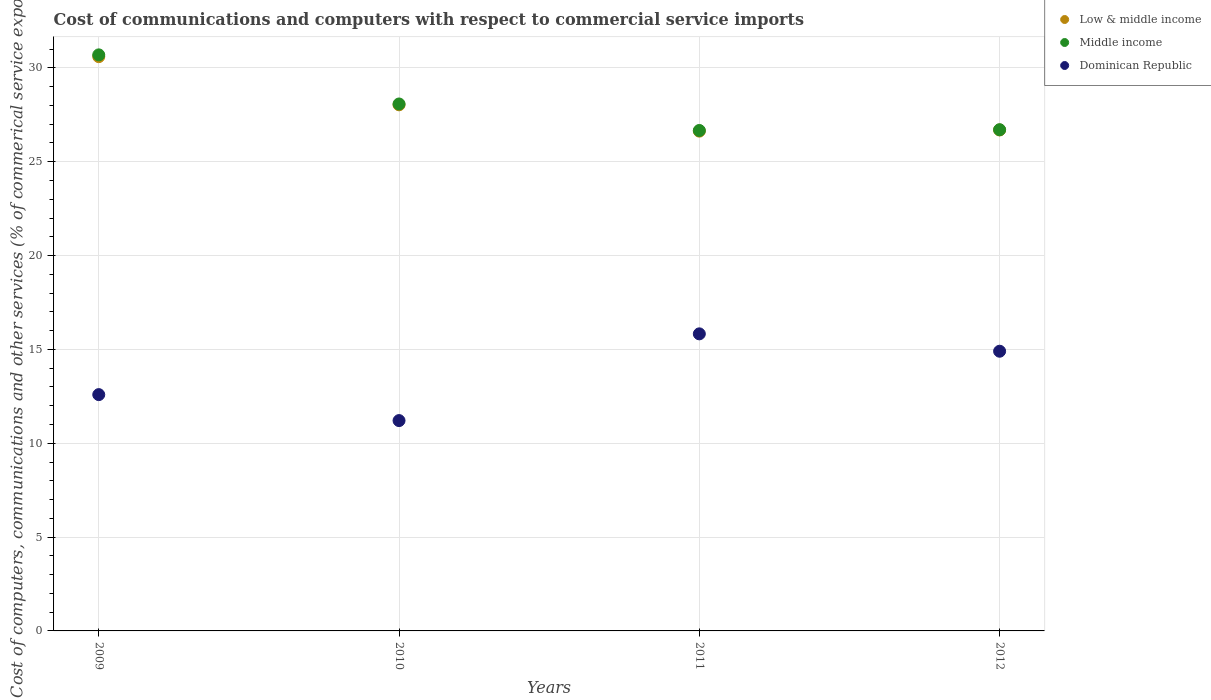Is the number of dotlines equal to the number of legend labels?
Give a very brief answer. Yes. What is the cost of communications and computers in Middle income in 2010?
Offer a terse response. 28.08. Across all years, what is the maximum cost of communications and computers in Dominican Republic?
Your response must be concise. 15.83. Across all years, what is the minimum cost of communications and computers in Middle income?
Your answer should be very brief. 26.66. In which year was the cost of communications and computers in Dominican Republic maximum?
Your answer should be compact. 2011. What is the total cost of communications and computers in Middle income in the graph?
Your answer should be very brief. 112.14. What is the difference between the cost of communications and computers in Dominican Republic in 2011 and that in 2012?
Ensure brevity in your answer.  0.93. What is the difference between the cost of communications and computers in Dominican Republic in 2012 and the cost of communications and computers in Low & middle income in 2009?
Provide a succinct answer. -15.7. What is the average cost of communications and computers in Middle income per year?
Make the answer very short. 28.03. In the year 2012, what is the difference between the cost of communications and computers in Middle income and cost of communications and computers in Low & middle income?
Offer a very short reply. 0.01. In how many years, is the cost of communications and computers in Middle income greater than 29 %?
Your answer should be very brief. 1. What is the ratio of the cost of communications and computers in Low & middle income in 2009 to that in 2010?
Ensure brevity in your answer.  1.09. Is the cost of communications and computers in Middle income in 2011 less than that in 2012?
Provide a short and direct response. Yes. What is the difference between the highest and the second highest cost of communications and computers in Dominican Republic?
Provide a succinct answer. 0.93. What is the difference between the highest and the lowest cost of communications and computers in Low & middle income?
Keep it short and to the point. 3.97. In how many years, is the cost of communications and computers in Low & middle income greater than the average cost of communications and computers in Low & middle income taken over all years?
Offer a terse response. 2. Is it the case that in every year, the sum of the cost of communications and computers in Middle income and cost of communications and computers in Low & middle income  is greater than the cost of communications and computers in Dominican Republic?
Your answer should be very brief. Yes. Does the cost of communications and computers in Dominican Republic monotonically increase over the years?
Keep it short and to the point. No. Is the cost of communications and computers in Middle income strictly less than the cost of communications and computers in Low & middle income over the years?
Your response must be concise. No. How many dotlines are there?
Keep it short and to the point. 3. Are the values on the major ticks of Y-axis written in scientific E-notation?
Provide a short and direct response. No. Does the graph contain any zero values?
Make the answer very short. No. How many legend labels are there?
Offer a very short reply. 3. What is the title of the graph?
Ensure brevity in your answer.  Cost of communications and computers with respect to commercial service imports. What is the label or title of the Y-axis?
Keep it short and to the point. Cost of computers, communications and other services (% of commerical service exports). What is the Cost of computers, communications and other services (% of commerical service exports) in Low & middle income in 2009?
Offer a terse response. 30.6. What is the Cost of computers, communications and other services (% of commerical service exports) in Middle income in 2009?
Provide a short and direct response. 30.69. What is the Cost of computers, communications and other services (% of commerical service exports) in Dominican Republic in 2009?
Offer a terse response. 12.59. What is the Cost of computers, communications and other services (% of commerical service exports) in Low & middle income in 2010?
Keep it short and to the point. 28.03. What is the Cost of computers, communications and other services (% of commerical service exports) in Middle income in 2010?
Make the answer very short. 28.08. What is the Cost of computers, communications and other services (% of commerical service exports) of Dominican Republic in 2010?
Provide a short and direct response. 11.21. What is the Cost of computers, communications and other services (% of commerical service exports) of Low & middle income in 2011?
Provide a succinct answer. 26.63. What is the Cost of computers, communications and other services (% of commerical service exports) of Middle income in 2011?
Provide a short and direct response. 26.66. What is the Cost of computers, communications and other services (% of commerical service exports) in Dominican Republic in 2011?
Your answer should be compact. 15.83. What is the Cost of computers, communications and other services (% of commerical service exports) in Low & middle income in 2012?
Make the answer very short. 26.69. What is the Cost of computers, communications and other services (% of commerical service exports) in Middle income in 2012?
Offer a terse response. 26.71. What is the Cost of computers, communications and other services (% of commerical service exports) in Dominican Republic in 2012?
Your answer should be compact. 14.9. Across all years, what is the maximum Cost of computers, communications and other services (% of commerical service exports) in Low & middle income?
Your response must be concise. 30.6. Across all years, what is the maximum Cost of computers, communications and other services (% of commerical service exports) in Middle income?
Make the answer very short. 30.69. Across all years, what is the maximum Cost of computers, communications and other services (% of commerical service exports) of Dominican Republic?
Keep it short and to the point. 15.83. Across all years, what is the minimum Cost of computers, communications and other services (% of commerical service exports) of Low & middle income?
Your answer should be very brief. 26.63. Across all years, what is the minimum Cost of computers, communications and other services (% of commerical service exports) of Middle income?
Keep it short and to the point. 26.66. Across all years, what is the minimum Cost of computers, communications and other services (% of commerical service exports) of Dominican Republic?
Your answer should be very brief. 11.21. What is the total Cost of computers, communications and other services (% of commerical service exports) in Low & middle income in the graph?
Make the answer very short. 111.95. What is the total Cost of computers, communications and other services (% of commerical service exports) in Middle income in the graph?
Keep it short and to the point. 112.14. What is the total Cost of computers, communications and other services (% of commerical service exports) in Dominican Republic in the graph?
Provide a short and direct response. 54.53. What is the difference between the Cost of computers, communications and other services (% of commerical service exports) of Low & middle income in 2009 and that in 2010?
Provide a succinct answer. 2.57. What is the difference between the Cost of computers, communications and other services (% of commerical service exports) of Middle income in 2009 and that in 2010?
Provide a succinct answer. 2.62. What is the difference between the Cost of computers, communications and other services (% of commerical service exports) in Dominican Republic in 2009 and that in 2010?
Your answer should be very brief. 1.38. What is the difference between the Cost of computers, communications and other services (% of commerical service exports) in Low & middle income in 2009 and that in 2011?
Provide a short and direct response. 3.97. What is the difference between the Cost of computers, communications and other services (% of commerical service exports) of Middle income in 2009 and that in 2011?
Your answer should be compact. 4.03. What is the difference between the Cost of computers, communications and other services (% of commerical service exports) of Dominican Republic in 2009 and that in 2011?
Your answer should be very brief. -3.24. What is the difference between the Cost of computers, communications and other services (% of commerical service exports) of Low & middle income in 2009 and that in 2012?
Keep it short and to the point. 3.91. What is the difference between the Cost of computers, communications and other services (% of commerical service exports) in Middle income in 2009 and that in 2012?
Provide a succinct answer. 3.99. What is the difference between the Cost of computers, communications and other services (% of commerical service exports) of Dominican Republic in 2009 and that in 2012?
Offer a very short reply. -2.31. What is the difference between the Cost of computers, communications and other services (% of commerical service exports) of Low & middle income in 2010 and that in 2011?
Your answer should be compact. 1.4. What is the difference between the Cost of computers, communications and other services (% of commerical service exports) of Middle income in 2010 and that in 2011?
Your answer should be very brief. 1.41. What is the difference between the Cost of computers, communications and other services (% of commerical service exports) in Dominican Republic in 2010 and that in 2011?
Give a very brief answer. -4.62. What is the difference between the Cost of computers, communications and other services (% of commerical service exports) of Low & middle income in 2010 and that in 2012?
Keep it short and to the point. 1.34. What is the difference between the Cost of computers, communications and other services (% of commerical service exports) in Middle income in 2010 and that in 2012?
Your answer should be compact. 1.37. What is the difference between the Cost of computers, communications and other services (% of commerical service exports) in Dominican Republic in 2010 and that in 2012?
Offer a very short reply. -3.7. What is the difference between the Cost of computers, communications and other services (% of commerical service exports) of Low & middle income in 2011 and that in 2012?
Keep it short and to the point. -0.06. What is the difference between the Cost of computers, communications and other services (% of commerical service exports) in Middle income in 2011 and that in 2012?
Offer a terse response. -0.04. What is the difference between the Cost of computers, communications and other services (% of commerical service exports) in Dominican Republic in 2011 and that in 2012?
Your response must be concise. 0.93. What is the difference between the Cost of computers, communications and other services (% of commerical service exports) of Low & middle income in 2009 and the Cost of computers, communications and other services (% of commerical service exports) of Middle income in 2010?
Make the answer very short. 2.52. What is the difference between the Cost of computers, communications and other services (% of commerical service exports) in Low & middle income in 2009 and the Cost of computers, communications and other services (% of commerical service exports) in Dominican Republic in 2010?
Offer a very short reply. 19.39. What is the difference between the Cost of computers, communications and other services (% of commerical service exports) in Middle income in 2009 and the Cost of computers, communications and other services (% of commerical service exports) in Dominican Republic in 2010?
Your answer should be very brief. 19.49. What is the difference between the Cost of computers, communications and other services (% of commerical service exports) in Low & middle income in 2009 and the Cost of computers, communications and other services (% of commerical service exports) in Middle income in 2011?
Keep it short and to the point. 3.93. What is the difference between the Cost of computers, communications and other services (% of commerical service exports) of Low & middle income in 2009 and the Cost of computers, communications and other services (% of commerical service exports) of Dominican Republic in 2011?
Your answer should be very brief. 14.77. What is the difference between the Cost of computers, communications and other services (% of commerical service exports) of Middle income in 2009 and the Cost of computers, communications and other services (% of commerical service exports) of Dominican Republic in 2011?
Provide a short and direct response. 14.87. What is the difference between the Cost of computers, communications and other services (% of commerical service exports) of Low & middle income in 2009 and the Cost of computers, communications and other services (% of commerical service exports) of Middle income in 2012?
Offer a terse response. 3.89. What is the difference between the Cost of computers, communications and other services (% of commerical service exports) in Low & middle income in 2009 and the Cost of computers, communications and other services (% of commerical service exports) in Dominican Republic in 2012?
Your response must be concise. 15.7. What is the difference between the Cost of computers, communications and other services (% of commerical service exports) of Middle income in 2009 and the Cost of computers, communications and other services (% of commerical service exports) of Dominican Republic in 2012?
Offer a very short reply. 15.79. What is the difference between the Cost of computers, communications and other services (% of commerical service exports) in Low & middle income in 2010 and the Cost of computers, communications and other services (% of commerical service exports) in Middle income in 2011?
Offer a very short reply. 1.37. What is the difference between the Cost of computers, communications and other services (% of commerical service exports) of Low & middle income in 2010 and the Cost of computers, communications and other services (% of commerical service exports) of Dominican Republic in 2011?
Offer a very short reply. 12.2. What is the difference between the Cost of computers, communications and other services (% of commerical service exports) in Middle income in 2010 and the Cost of computers, communications and other services (% of commerical service exports) in Dominican Republic in 2011?
Keep it short and to the point. 12.25. What is the difference between the Cost of computers, communications and other services (% of commerical service exports) of Low & middle income in 2010 and the Cost of computers, communications and other services (% of commerical service exports) of Middle income in 2012?
Give a very brief answer. 1.33. What is the difference between the Cost of computers, communications and other services (% of commerical service exports) of Low & middle income in 2010 and the Cost of computers, communications and other services (% of commerical service exports) of Dominican Republic in 2012?
Provide a short and direct response. 13.13. What is the difference between the Cost of computers, communications and other services (% of commerical service exports) of Middle income in 2010 and the Cost of computers, communications and other services (% of commerical service exports) of Dominican Republic in 2012?
Provide a succinct answer. 13.17. What is the difference between the Cost of computers, communications and other services (% of commerical service exports) in Low & middle income in 2011 and the Cost of computers, communications and other services (% of commerical service exports) in Middle income in 2012?
Ensure brevity in your answer.  -0.08. What is the difference between the Cost of computers, communications and other services (% of commerical service exports) in Low & middle income in 2011 and the Cost of computers, communications and other services (% of commerical service exports) in Dominican Republic in 2012?
Your response must be concise. 11.73. What is the difference between the Cost of computers, communications and other services (% of commerical service exports) in Middle income in 2011 and the Cost of computers, communications and other services (% of commerical service exports) in Dominican Republic in 2012?
Offer a very short reply. 11.76. What is the average Cost of computers, communications and other services (% of commerical service exports) of Low & middle income per year?
Your answer should be compact. 27.99. What is the average Cost of computers, communications and other services (% of commerical service exports) of Middle income per year?
Keep it short and to the point. 28.03. What is the average Cost of computers, communications and other services (% of commerical service exports) in Dominican Republic per year?
Provide a succinct answer. 13.63. In the year 2009, what is the difference between the Cost of computers, communications and other services (% of commerical service exports) of Low & middle income and Cost of computers, communications and other services (% of commerical service exports) of Middle income?
Give a very brief answer. -0.1. In the year 2009, what is the difference between the Cost of computers, communications and other services (% of commerical service exports) in Low & middle income and Cost of computers, communications and other services (% of commerical service exports) in Dominican Republic?
Provide a succinct answer. 18.01. In the year 2009, what is the difference between the Cost of computers, communications and other services (% of commerical service exports) of Middle income and Cost of computers, communications and other services (% of commerical service exports) of Dominican Republic?
Provide a short and direct response. 18.1. In the year 2010, what is the difference between the Cost of computers, communications and other services (% of commerical service exports) in Low & middle income and Cost of computers, communications and other services (% of commerical service exports) in Middle income?
Keep it short and to the point. -0.05. In the year 2010, what is the difference between the Cost of computers, communications and other services (% of commerical service exports) in Low & middle income and Cost of computers, communications and other services (% of commerical service exports) in Dominican Republic?
Offer a terse response. 16.82. In the year 2010, what is the difference between the Cost of computers, communications and other services (% of commerical service exports) in Middle income and Cost of computers, communications and other services (% of commerical service exports) in Dominican Republic?
Keep it short and to the point. 16.87. In the year 2011, what is the difference between the Cost of computers, communications and other services (% of commerical service exports) in Low & middle income and Cost of computers, communications and other services (% of commerical service exports) in Middle income?
Your answer should be very brief. -0.04. In the year 2011, what is the difference between the Cost of computers, communications and other services (% of commerical service exports) in Low & middle income and Cost of computers, communications and other services (% of commerical service exports) in Dominican Republic?
Provide a short and direct response. 10.8. In the year 2011, what is the difference between the Cost of computers, communications and other services (% of commerical service exports) of Middle income and Cost of computers, communications and other services (% of commerical service exports) of Dominican Republic?
Ensure brevity in your answer.  10.84. In the year 2012, what is the difference between the Cost of computers, communications and other services (% of commerical service exports) in Low & middle income and Cost of computers, communications and other services (% of commerical service exports) in Middle income?
Give a very brief answer. -0.01. In the year 2012, what is the difference between the Cost of computers, communications and other services (% of commerical service exports) in Low & middle income and Cost of computers, communications and other services (% of commerical service exports) in Dominican Republic?
Give a very brief answer. 11.79. In the year 2012, what is the difference between the Cost of computers, communications and other services (% of commerical service exports) of Middle income and Cost of computers, communications and other services (% of commerical service exports) of Dominican Republic?
Offer a terse response. 11.8. What is the ratio of the Cost of computers, communications and other services (% of commerical service exports) of Low & middle income in 2009 to that in 2010?
Your answer should be very brief. 1.09. What is the ratio of the Cost of computers, communications and other services (% of commerical service exports) of Middle income in 2009 to that in 2010?
Make the answer very short. 1.09. What is the ratio of the Cost of computers, communications and other services (% of commerical service exports) of Dominican Republic in 2009 to that in 2010?
Your answer should be compact. 1.12. What is the ratio of the Cost of computers, communications and other services (% of commerical service exports) in Low & middle income in 2009 to that in 2011?
Ensure brevity in your answer.  1.15. What is the ratio of the Cost of computers, communications and other services (% of commerical service exports) in Middle income in 2009 to that in 2011?
Your response must be concise. 1.15. What is the ratio of the Cost of computers, communications and other services (% of commerical service exports) in Dominican Republic in 2009 to that in 2011?
Offer a terse response. 0.8. What is the ratio of the Cost of computers, communications and other services (% of commerical service exports) in Low & middle income in 2009 to that in 2012?
Offer a very short reply. 1.15. What is the ratio of the Cost of computers, communications and other services (% of commerical service exports) of Middle income in 2009 to that in 2012?
Offer a very short reply. 1.15. What is the ratio of the Cost of computers, communications and other services (% of commerical service exports) of Dominican Republic in 2009 to that in 2012?
Give a very brief answer. 0.84. What is the ratio of the Cost of computers, communications and other services (% of commerical service exports) in Low & middle income in 2010 to that in 2011?
Provide a short and direct response. 1.05. What is the ratio of the Cost of computers, communications and other services (% of commerical service exports) of Middle income in 2010 to that in 2011?
Ensure brevity in your answer.  1.05. What is the ratio of the Cost of computers, communications and other services (% of commerical service exports) of Dominican Republic in 2010 to that in 2011?
Provide a succinct answer. 0.71. What is the ratio of the Cost of computers, communications and other services (% of commerical service exports) in Low & middle income in 2010 to that in 2012?
Offer a very short reply. 1.05. What is the ratio of the Cost of computers, communications and other services (% of commerical service exports) in Middle income in 2010 to that in 2012?
Give a very brief answer. 1.05. What is the ratio of the Cost of computers, communications and other services (% of commerical service exports) of Dominican Republic in 2010 to that in 2012?
Your response must be concise. 0.75. What is the ratio of the Cost of computers, communications and other services (% of commerical service exports) in Low & middle income in 2011 to that in 2012?
Keep it short and to the point. 1. What is the ratio of the Cost of computers, communications and other services (% of commerical service exports) in Dominican Republic in 2011 to that in 2012?
Make the answer very short. 1.06. What is the difference between the highest and the second highest Cost of computers, communications and other services (% of commerical service exports) in Low & middle income?
Your answer should be compact. 2.57. What is the difference between the highest and the second highest Cost of computers, communications and other services (% of commerical service exports) of Middle income?
Your response must be concise. 2.62. What is the difference between the highest and the second highest Cost of computers, communications and other services (% of commerical service exports) of Dominican Republic?
Provide a succinct answer. 0.93. What is the difference between the highest and the lowest Cost of computers, communications and other services (% of commerical service exports) in Low & middle income?
Keep it short and to the point. 3.97. What is the difference between the highest and the lowest Cost of computers, communications and other services (% of commerical service exports) of Middle income?
Make the answer very short. 4.03. What is the difference between the highest and the lowest Cost of computers, communications and other services (% of commerical service exports) of Dominican Republic?
Make the answer very short. 4.62. 